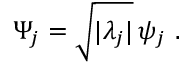<formula> <loc_0><loc_0><loc_500><loc_500>\Psi _ { j } = \sqrt { | \lambda _ { j } | } \, \psi _ { j } .</formula> 